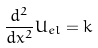Convert formula to latex. <formula><loc_0><loc_0><loc_500><loc_500>\frac { d ^ { 2 } } { d x ^ { 2 } } U _ { e l } = k</formula> 